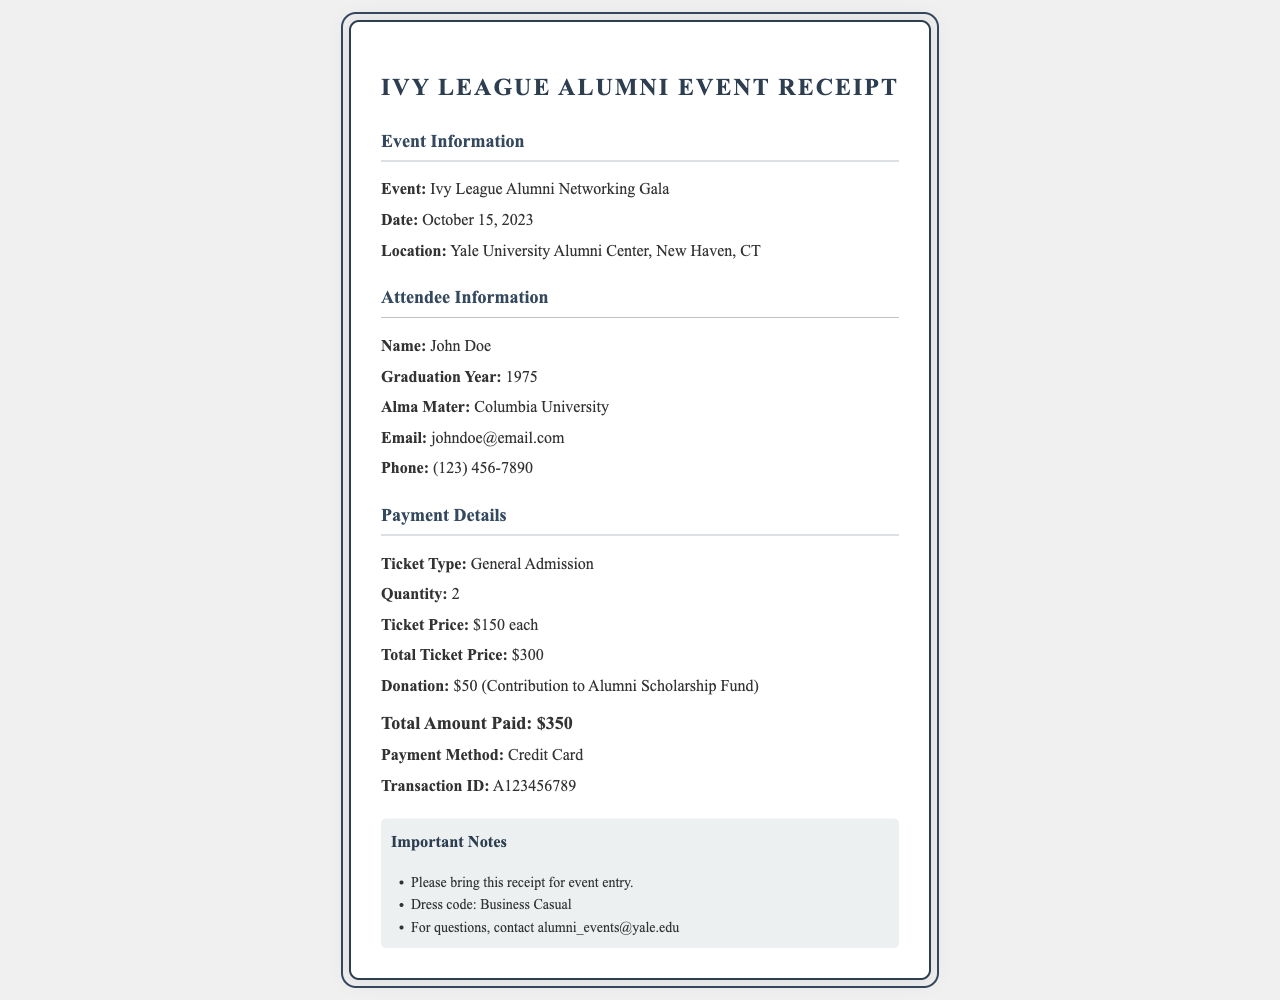What is the event name? The event name is clearly stated in the document under the event information section.
Answer: Ivy League Alumni Networking Gala What is the location of the event? The location of the event is mentioned in the event details section of the document.
Answer: Yale University Alumni Center, New Haven, CT What is the total amount paid? The total amount paid is calculated and clearly listed in the payment details section.
Answer: $350 What is the ticket price for general admission? The ticket price is provided in the payment details section of the receipt.
Answer: $150 each How many tickets were purchased? The quantity of tickets purchased is specified in the payment details section.
Answer: 2 What is the transaction ID? The transaction ID is uniquely identified in the payment details and is critical for record-keeping.
Answer: A123456789 What is the donation amount? The donation amount is indicated in the payment details and is relevant for contributions made during the event.
Answer: $50 What is the dress code for the event? The dress code information is included in the notes section of the document.
Answer: Business Casual What is the email for event inquiries? The contact email for questions is provided in the notes section of the receipt.
Answer: alumni_events@yale.edu 